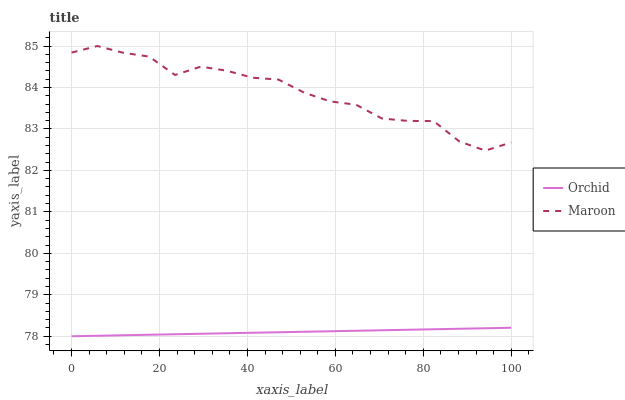Does Orchid have the minimum area under the curve?
Answer yes or no. Yes. Does Maroon have the maximum area under the curve?
Answer yes or no. Yes. Does Orchid have the maximum area under the curve?
Answer yes or no. No. Is Orchid the smoothest?
Answer yes or no. Yes. Is Maroon the roughest?
Answer yes or no. Yes. Is Orchid the roughest?
Answer yes or no. No. Does Maroon have the highest value?
Answer yes or no. Yes. Does Orchid have the highest value?
Answer yes or no. No. Is Orchid less than Maroon?
Answer yes or no. Yes. Is Maroon greater than Orchid?
Answer yes or no. Yes. Does Orchid intersect Maroon?
Answer yes or no. No. 